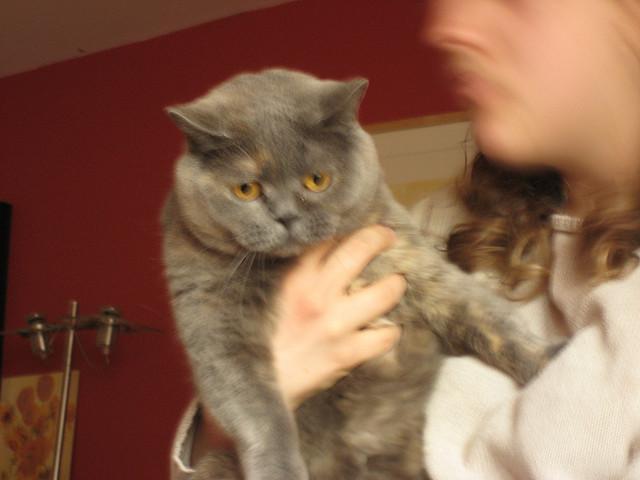How many boats are moving in the photo?
Give a very brief answer. 0. 